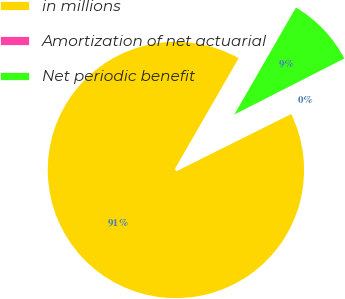Convert chart to OTSL. <chart><loc_0><loc_0><loc_500><loc_500><pie_chart><fcel>in millions<fcel>Amortization of net actuarial<fcel>Net periodic benefit<nl><fcel>90.68%<fcel>0.14%<fcel>9.19%<nl></chart> 